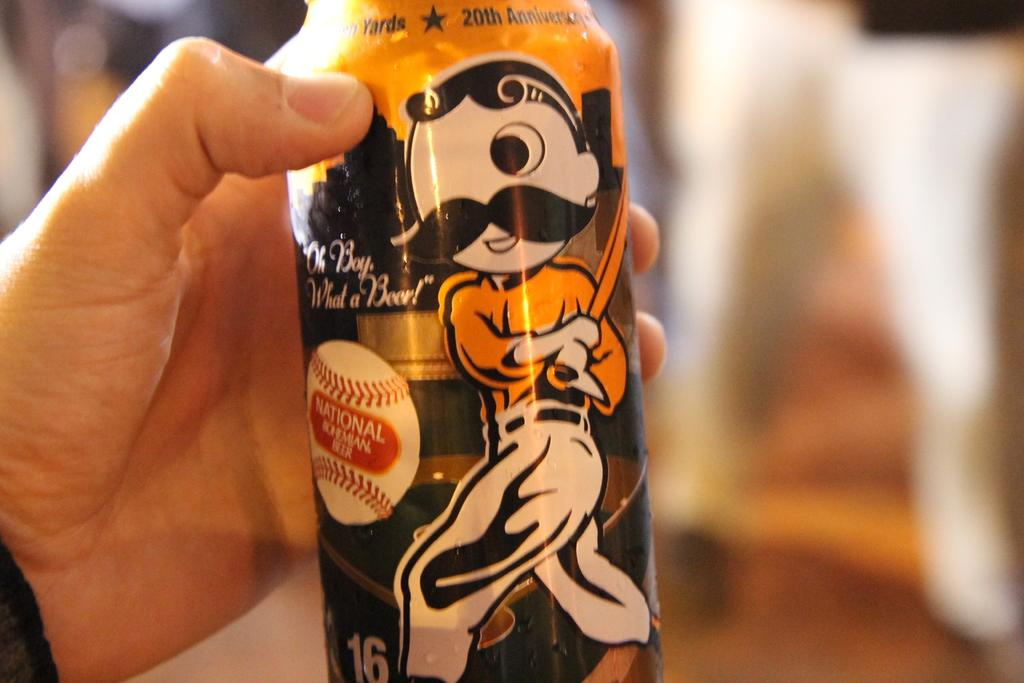Provide a one-sentence caption for the provided image. The beer can that is held by a hand has a cartoon figure playing baseball and the words "Oh Boy, What a Beer!" on it. 